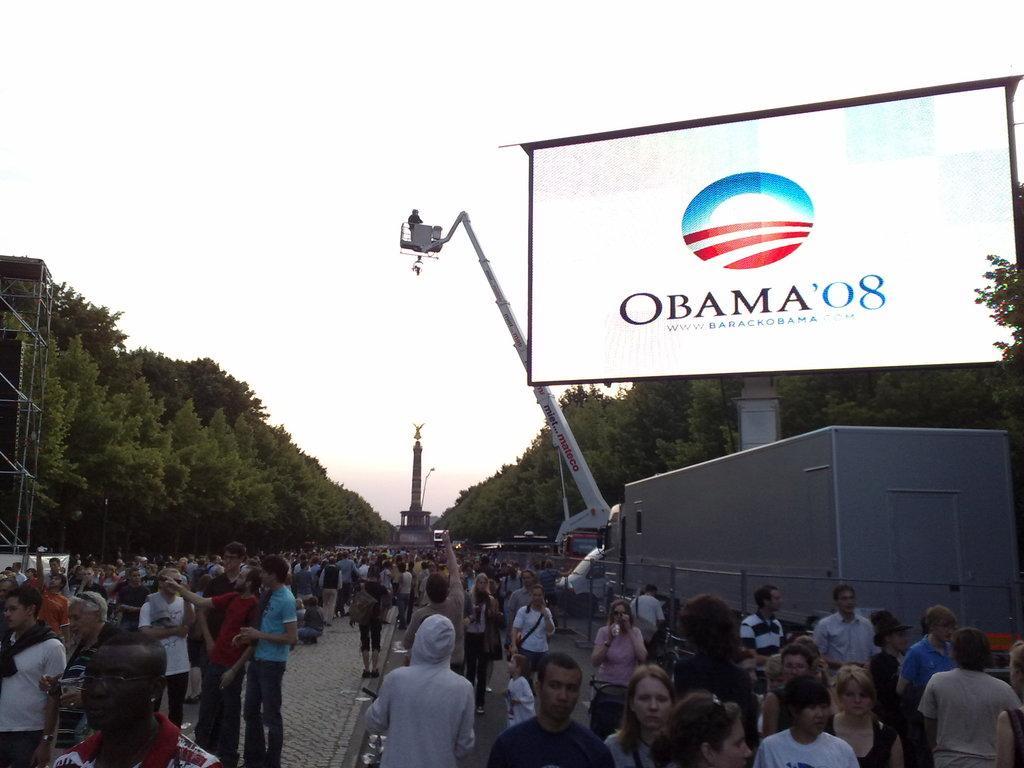Can you describe this image briefly? In this picture we can see a group of people standing on the path and behind the people there is a pole, crane, screen and trees. Behind the trees there is a sky. 